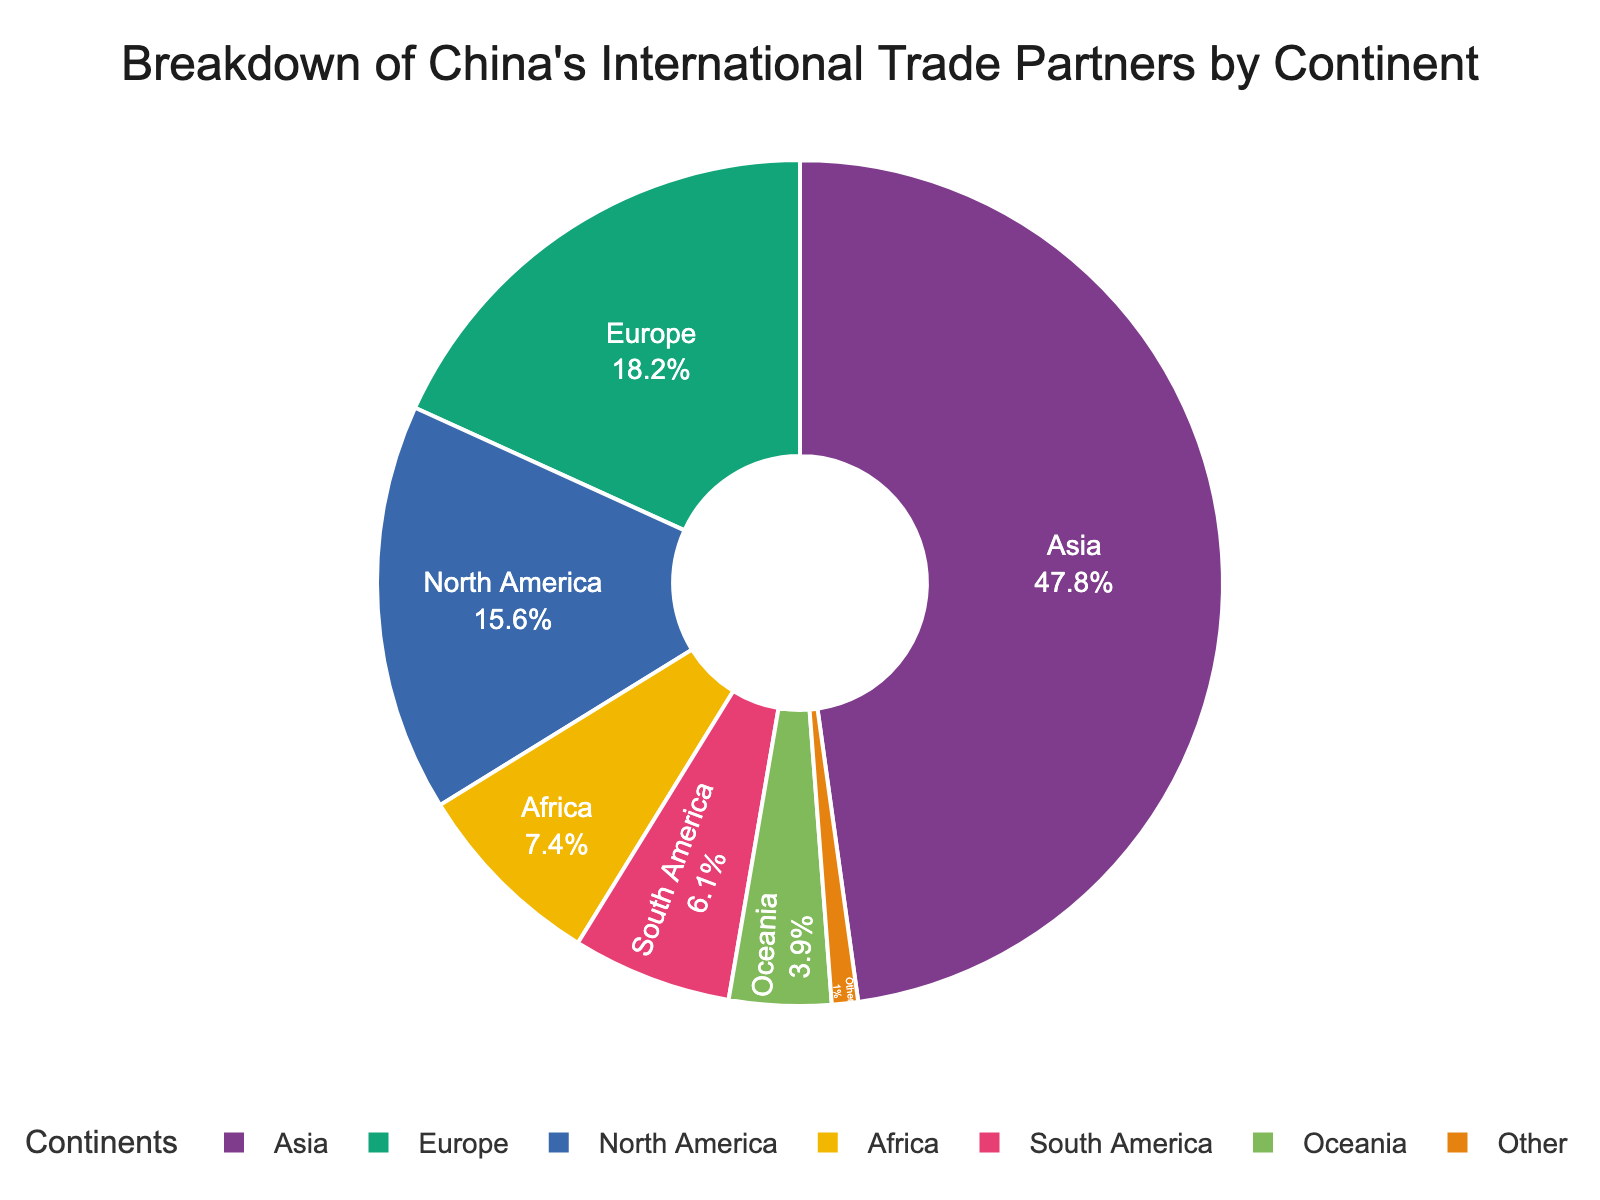Which continent has the highest percentage of China's international trade partners? The figure shows the breakdown of China's international trade partners by continent. Asia has the largest segment, indicating it has the highest percentage.
Answer: Asia Which continent has the lowest percentage of China's international trade partners? The smallest segment in the pie chart represents the continent with the lowest percentage. The segment labeled "Other" is the smallest one.
Answer: Other What is the total percentage of China's international trade partners in Africa and Oceania combined? To find the total percentage for Africa and Oceania, sum their individual percentages: 7.4% (Africa) + 3.9% (Oceania) = 11.3%.
Answer: 11.3% Is the percentage of China's international trade in Asia greater than the combined percentage of Europe and North America? Asia has 47.8%. The combined percentage of Europe and North America is 18.2% + 15.6% = 33.8%. Since 47.8% > 33.8%, Asia's percentage is indeed greater.
Answer: Yes What is the difference in percentage between Africa and South America in the context of China's international trade partners? Africa has 7.4% and South America has 6.1%. The difference is 7.4% - 6.1% = 1.3%.
Answer: 1.3% Which two continents have the closest percentage values and what are these percentages? By observing the pie chart, Oceania (3.9%) and "Other" (1.0%) have the closest percentages among larger continents/sub-categories like Asia, Europe, etc. Therefore, the closest percentages among major continents are South America (6.1%) and Oceania (3.9%). The difference is closest when comparing Oceania and South America.
Answer: South America (6.1%) and Oceania (3.9%) Calculate the total percentage of China’s international trade partners that are in continents other than Asia. The total percentage calculated would be Europe (18.2%) + North America (15.6%) + Africa (7.4%) + South America (6.1%) + Oceania (3.9%) + Other (1.0%). The resulting sum is 18.2 + 15.6 + 7.4 + 6.1 + 3.9 + 1.0 = 52.2%.
Answer: 52.2% Compare the sum of percentages of Europe and Africa with the percentage of North America. Which one is higher and by how much? The sum of percentages of Europe and Africa is 18.2% + 7.4% = 25.6%. North America's percentage is 15.6%. The difference is 25.6% - 15.6% = 10.0%. Therefore, the sum for Europe and Africa is higher by 10.0%.
Answer: Europe and Africa; 10.0% What would the percentage for North and South America combined be, and how does it compare to Europe's percentage? North America has 15.6% and South America has 6.1%. The combined percentage is 15.6% + 6.1% = 21.7%. Europe's percentage is 18.2%, and the combined percentage for North and South America is higher by 21.7% - 18.2% = 3.5%.
Answer: 21.7%; higher by 3.5% What is the median percentage value of China's international trade partners by continent? The percentages are: 47.8 (Asia), 18.2 (Europe), 15.6 (North America), 7.4 (Africa), 6.1 (South America), 3.9 (Oceania), 1.0 (Other). Arranging them in ascending order: 1.0, 3.9, 6.1, 7.4, 15.6, 18.2, 47.8. The median value is the middle number, which is 7.4 (Africa).
Answer: 7.4 